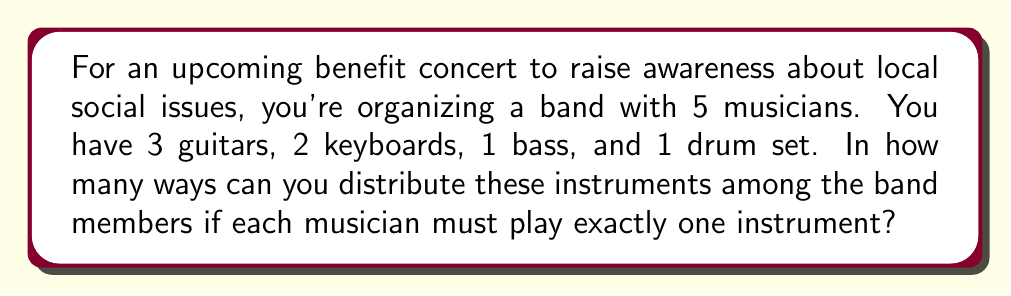Show me your answer to this math problem. Let's approach this step-by-step:

1) First, we need to choose who will play the drum set. There's only one drum set and it must be played, so we have 5 choices for this.

2) After the drummer is chosen, we have 4 musicians left and 6 instruments (3 guitars, 2 keyboards, 1 bass).

3) Now, let's consider the remaining distributions as a sequence of choices:
   - We have 4 choices for who plays the bass
   - Then 3 choices for who takes a keyboard
   - The remaining 2 musicians will play guitars

4) This scenario can be represented mathematically as:

   $$ 5 \times 4 \times 3 \times 2! $$

   Where:
   - 5 is the number of choices for the drummer
   - 4 is the number of choices for the bassist
   - 3 is the number of choices for a keyboard player
   - 2! represents the number of ways to distribute the guitars to the remaining 2 musicians

5) Calculating this:
   $$ 5 \times 4 \times 3 \times 2 = 120 $$

Therefore, there are 120 ways to distribute the instruments among the band members.
Answer: 120 ways 